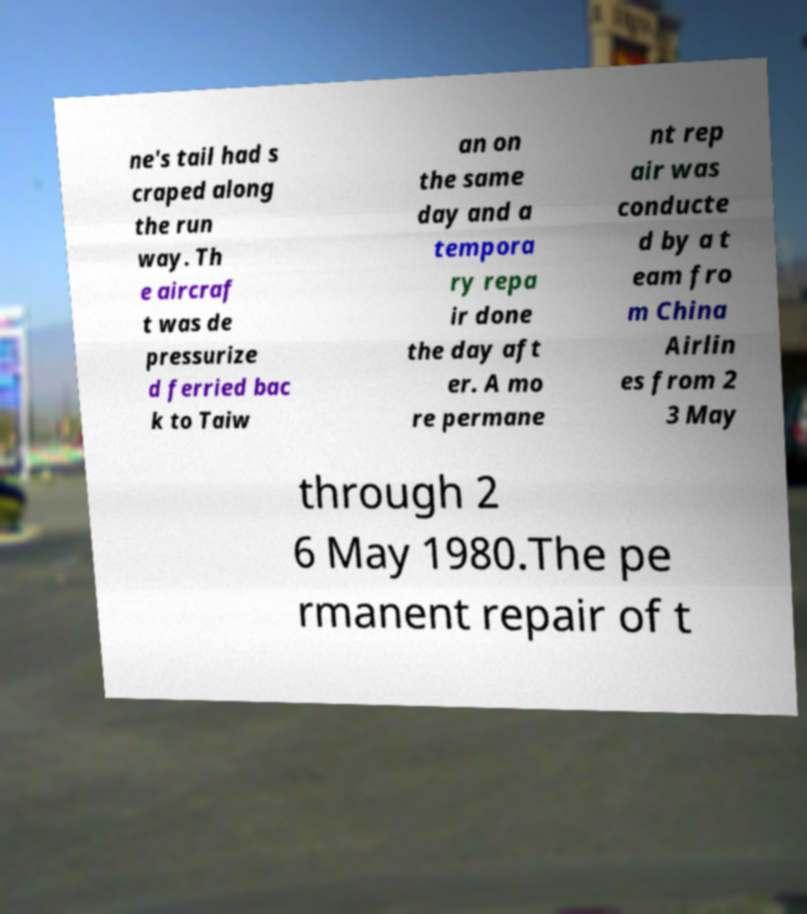I need the written content from this picture converted into text. Can you do that? ne's tail had s craped along the run way. Th e aircraf t was de pressurize d ferried bac k to Taiw an on the same day and a tempora ry repa ir done the day aft er. A mo re permane nt rep air was conducte d by a t eam fro m China Airlin es from 2 3 May through 2 6 May 1980.The pe rmanent repair of t 